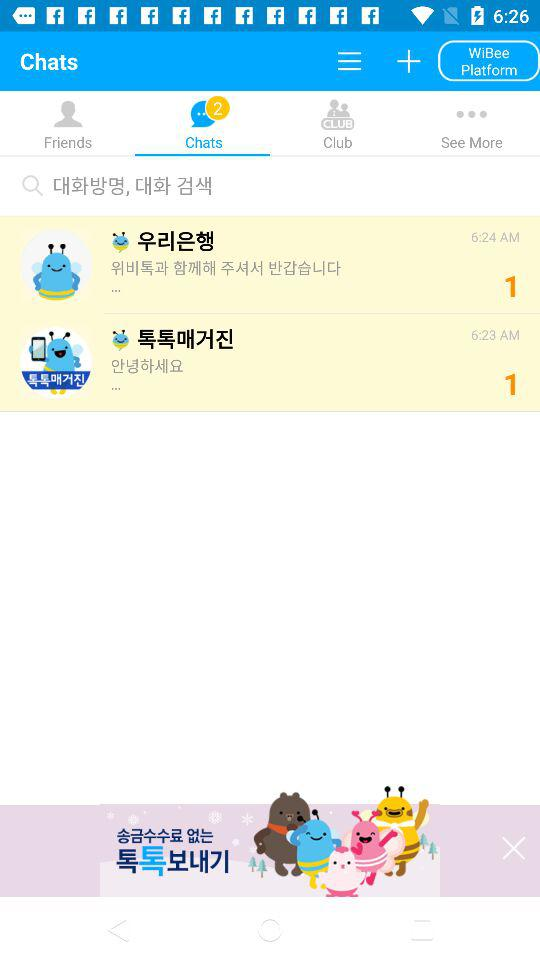How many terms are there in total?
Answer the question using a single word or phrase. 3 